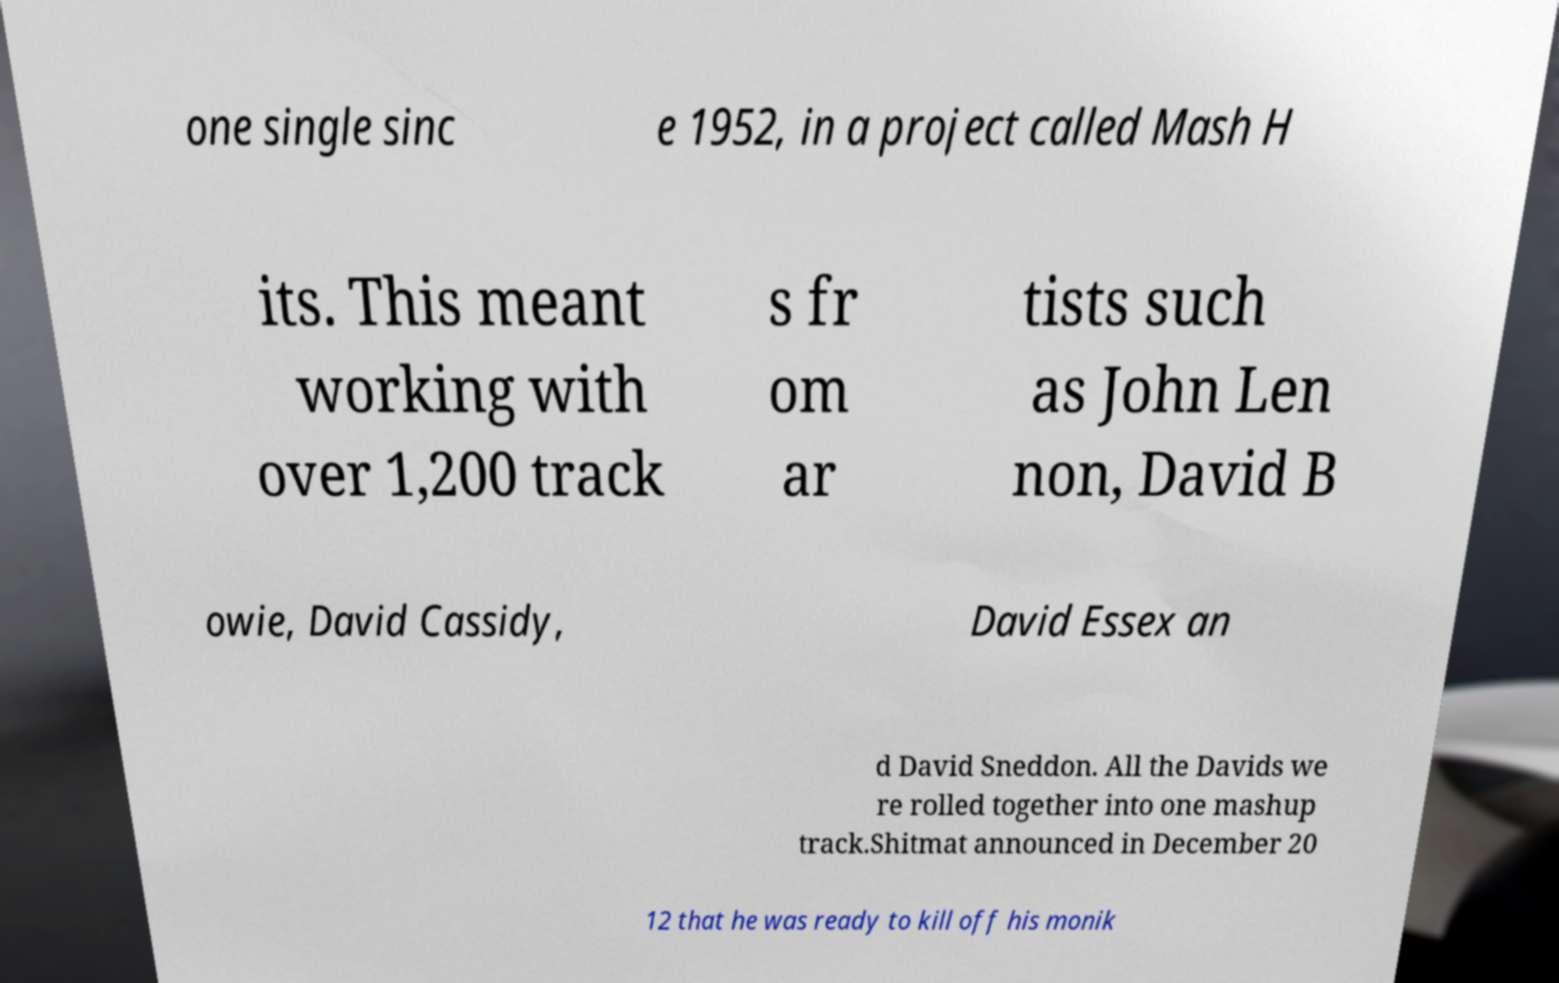Can you read and provide the text displayed in the image?This photo seems to have some interesting text. Can you extract and type it out for me? one single sinc e 1952, in a project called Mash H its. This meant working with over 1,200 track s fr om ar tists such as John Len non, David B owie, David Cassidy, David Essex an d David Sneddon. All the Davids we re rolled together into one mashup track.Shitmat announced in December 20 12 that he was ready to kill off his monik 